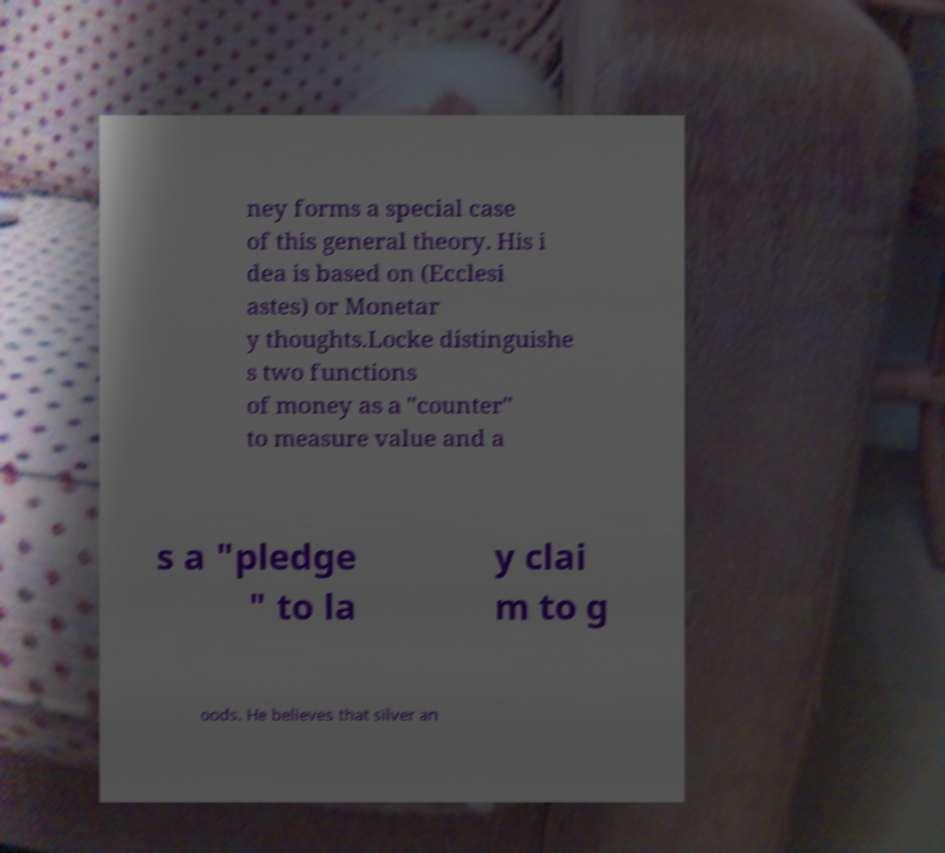Could you extract and type out the text from this image? ney forms a special case of this general theory. His i dea is based on (Ecclesi astes) or Monetar y thoughts.Locke distinguishe s two functions of money as a "counter" to measure value and a s a "pledge " to la y clai m to g oods. He believes that silver an 